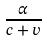Convert formula to latex. <formula><loc_0><loc_0><loc_500><loc_500>\frac { \alpha } { c + v }</formula> 